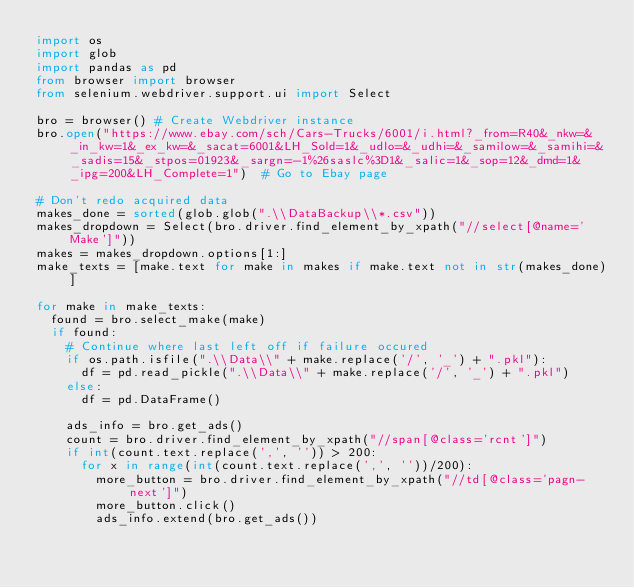Convert code to text. <code><loc_0><loc_0><loc_500><loc_500><_Python_>import os
import glob
import pandas as pd
from browser import browser
from selenium.webdriver.support.ui import Select

bro = browser()	# Create Webdriver instance
bro.open("https://www.ebay.com/sch/Cars-Trucks/6001/i.html?_from=R40&_nkw=&_in_kw=1&_ex_kw=&_sacat=6001&LH_Sold=1&_udlo=&_udhi=&_samilow=&_samihi=&_sadis=15&_stpos=01923&_sargn=-1%26saslc%3D1&_salic=1&_sop=12&_dmd=1&_ipg=200&LH_Complete=1")	# Go to Ebay page

# Don't redo acquired data
makes_done = sorted(glob.glob(".\\DataBackup\\*.csv"))
makes_dropdown = Select(bro.driver.find_element_by_xpath("//select[@name='Make']"))
makes = makes_dropdown.options[1:]
make_texts = [make.text for make in makes if make.text not in str(makes_done)]

for make in make_texts:
	found = bro.select_make(make)
	if found:
		# Continue where last left off if failure occured
		if os.path.isfile(".\\Data\\" + make.replace('/', '_') + ".pkl"):
			df = pd.read_pickle(".\\Data\\" + make.replace('/', '_') + ".pkl")
		else:
			df = pd.DataFrame()
		
		ads_info = bro.get_ads()
		count = bro.driver.find_element_by_xpath("//span[@class='rcnt']")
		if int(count.text.replace(',', '')) > 200:
			for x in range(int(count.text.replace(',', ''))/200):
				more_button = bro.driver.find_element_by_xpath("//td[@class='pagn-next']")
				more_button.click()
				ads_info.extend(bro.get_ads())
</code> 